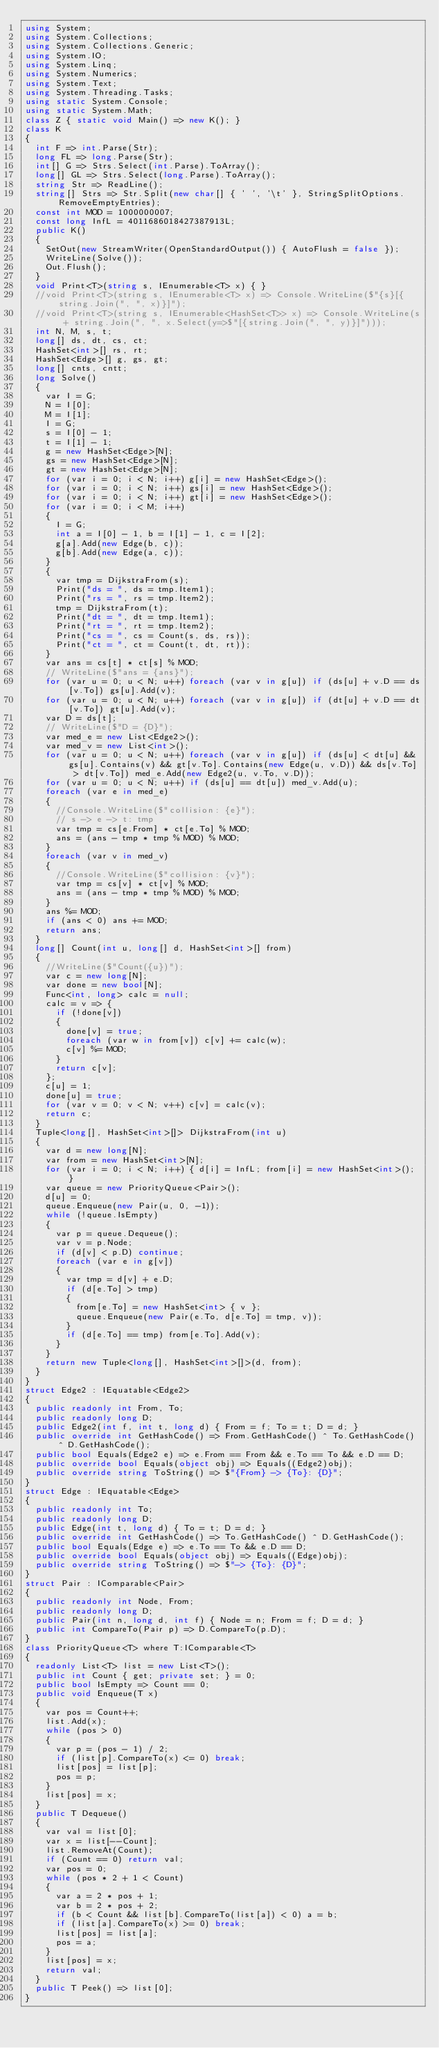<code> <loc_0><loc_0><loc_500><loc_500><_C#_>using System;
using System.Collections;
using System.Collections.Generic;
using System.IO;
using System.Linq;
using System.Numerics;
using System.Text;
using System.Threading.Tasks;
using static System.Console;
using static System.Math;
class Z { static void Main() => new K(); }
class K
{
	int F => int.Parse(Str);
	long FL => long.Parse(Str);
	int[] G => Strs.Select(int.Parse).ToArray();
	long[] GL => Strs.Select(long.Parse).ToArray();
	string Str => ReadLine();
	string[] Strs => Str.Split(new char[] { ' ', '\t' }, StringSplitOptions.RemoveEmptyEntries);
	const int MOD = 1000000007;
	const long InfL = 4011686018427387913L;
	public K()
	{
		SetOut(new StreamWriter(OpenStandardOutput()) { AutoFlush = false });
		WriteLine(Solve());
		Out.Flush();
	}
	void Print<T>(string s, IEnumerable<T> x) { }
	//void Print<T>(string s, IEnumerable<T> x) => Console.WriteLine($"{s}[{string.Join(", ", x)}]");
	//void Print<T>(string s, IEnumerable<HashSet<T>> x) => Console.WriteLine(s + string.Join(", ", x.Select(y=>$"[{string.Join(", ", y)}]")));
	int N, M, s, t;
	long[] ds, dt, cs, ct;
	HashSet<int>[] rs, rt;
	HashSet<Edge>[] g, gs, gt;
	long[] cnts, cntt;
	long Solve()
	{
		var I = G;
		N = I[0];
		M = I[1];
		I = G;
		s = I[0] - 1;
		t = I[1] - 1;
		g = new HashSet<Edge>[N];
		gs = new HashSet<Edge>[N];
		gt = new HashSet<Edge>[N];
		for (var i = 0; i < N; i++) g[i] = new HashSet<Edge>();
		for (var i = 0; i < N; i++) gs[i] = new HashSet<Edge>();
		for (var i = 0; i < N; i++) gt[i] = new HashSet<Edge>();
		for (var i = 0; i < M; i++)
		{
			I = G;
			int a = I[0] - 1, b = I[1] - 1, c = I[2];
			g[a].Add(new Edge(b, c));
			g[b].Add(new Edge(a, c));
		}
		{
			var tmp = DijkstraFrom(s);
			Print("ds = ", ds = tmp.Item1);
			Print("rs = ", rs = tmp.Item2);
			tmp = DijkstraFrom(t);
			Print("dt = ", dt = tmp.Item1);
			Print("rt = ", rt = tmp.Item2);
			Print("cs = ", cs = Count(s, ds, rs));
			Print("ct = ", ct = Count(t, dt, rt));
		}
		var ans = cs[t] * ct[s] % MOD;
		// WriteLine($"ans = {ans}");
		for (var u = 0; u < N; u++) foreach (var v in g[u]) if (ds[u] + v.D == ds[v.To]) gs[u].Add(v);
		for (var u = 0; u < N; u++) foreach (var v in g[u]) if (dt[u] + v.D == dt[v.To]) gt[u].Add(v);
		var D = ds[t];
		// WriteLine($"D = {D}");
		var med_e = new List<Edge2>();
		var med_v = new List<int>();
		for (var u = 0; u < N; u++) foreach (var v in g[u]) if (ds[u] < dt[u] && gs[u].Contains(v) && gt[v.To].Contains(new Edge(u, v.D)) && ds[v.To] > dt[v.To]) med_e.Add(new Edge2(u, v.To, v.D));
		for (var u = 0; u < N; u++) if (ds[u] == dt[u]) med_v.Add(u);
		foreach (var e in med_e)
		{
			//Console.WriteLine($"collision: {e}");
			// s -> e -> t: tmp
			var tmp = cs[e.From] * ct[e.To] % MOD;
			ans = (ans - tmp * tmp % MOD) % MOD;
		}
		foreach (var v in med_v)
		{
			//Console.WriteLine($"collision: {v}");
			var tmp = cs[v] * ct[v] % MOD;
			ans = (ans - tmp * tmp % MOD) % MOD;
		}
		ans %= MOD;
		if (ans < 0) ans += MOD;
		return ans;
	}
	long[] Count(int u, long[] d, HashSet<int>[] from)
	{
		//WriteLine($"Count({u})");
		var c = new long[N];
		var done = new bool[N];
		Func<int, long> calc = null;
		calc = v => {
			if (!done[v])
			{
				done[v] = true;
				foreach (var w in from[v]) c[v] += calc(w);
				c[v] %= MOD;
			}
			return c[v];
		};
		c[u] = 1;
		done[u] = true;
		for (var v = 0; v < N; v++) c[v] = calc(v);
		return c;
	}
	Tuple<long[], HashSet<int>[]> DijkstraFrom(int u)
	{
		var d = new long[N];
		var from = new HashSet<int>[N];
		for (var i = 0; i < N; i++) { d[i] = InfL; from[i] = new HashSet<int>(); }
		var queue = new PriorityQueue<Pair>();
		d[u] = 0;
		queue.Enqueue(new Pair(u, 0, -1));
		while (!queue.IsEmpty)
		{
			var p = queue.Dequeue();
			var v = p.Node;
			if (d[v] < p.D) continue;
			foreach (var e in g[v])
			{
				var tmp = d[v] + e.D;
				if (d[e.To] > tmp)
				{
					from[e.To] = new HashSet<int> { v };
					queue.Enqueue(new Pair(e.To, d[e.To] = tmp, v));
				}
				if (d[e.To] == tmp) from[e.To].Add(v);
			}
		}
		return new Tuple<long[], HashSet<int>[]>(d, from);
	}
}
struct Edge2 : IEquatable<Edge2>
{
	public readonly int From, To;
	public readonly long D;
	public Edge2(int f, int t, long d) { From = f; To = t; D = d; }
	public override int GetHashCode() => From.GetHashCode() ^ To.GetHashCode() ^ D.GetHashCode();
	public bool Equals(Edge2 e) => e.From == From && e.To == To && e.D == D;
	public override bool Equals(object obj) => Equals((Edge2)obj);
	public override string ToString() => $"{From} -> {To}: {D}";
}
struct Edge : IEquatable<Edge>
{
	public readonly int To;
	public readonly long D;
	public Edge(int t, long d) { To = t; D = d; }
	public override int GetHashCode() => To.GetHashCode() ^ D.GetHashCode();
	public bool Equals(Edge e) => e.To == To && e.D == D;
	public override bool Equals(object obj) => Equals((Edge)obj);
	public override string ToString() => $"-> {To}: {D}";
}
struct Pair : IComparable<Pair>
{
	public readonly int Node, From;
	public readonly long D;
	public Pair(int n, long d, int f) { Node = n; From = f; D = d; }
	public int CompareTo(Pair p) => D.CompareTo(p.D);
}
class PriorityQueue<T> where T:IComparable<T>
{
	readonly List<T> list = new List<T>();
	public int Count { get; private set; } = 0;
	public bool IsEmpty => Count == 0;
	public void Enqueue(T x)
	{
		var pos = Count++;
		list.Add(x);
		while (pos > 0)
		{
			var p = (pos - 1) / 2;
			if (list[p].CompareTo(x) <= 0) break;
			list[pos] = list[p];
			pos = p;
		}
		list[pos] = x;
	}
	public T Dequeue()
	{
		var val = list[0];
		var x = list[--Count];
		list.RemoveAt(Count);
		if (Count == 0) return val;
		var pos = 0;
		while (pos * 2 + 1 < Count)
		{
			var a = 2 * pos + 1;
			var b = 2 * pos + 2;
			if (b < Count && list[b].CompareTo(list[a]) < 0) a = b;
			if (list[a].CompareTo(x) >= 0) break;
			list[pos] = list[a];
			pos = a;
		}
		list[pos] = x;
		return val;
	}
	public T Peek() => list[0];
}
</code> 